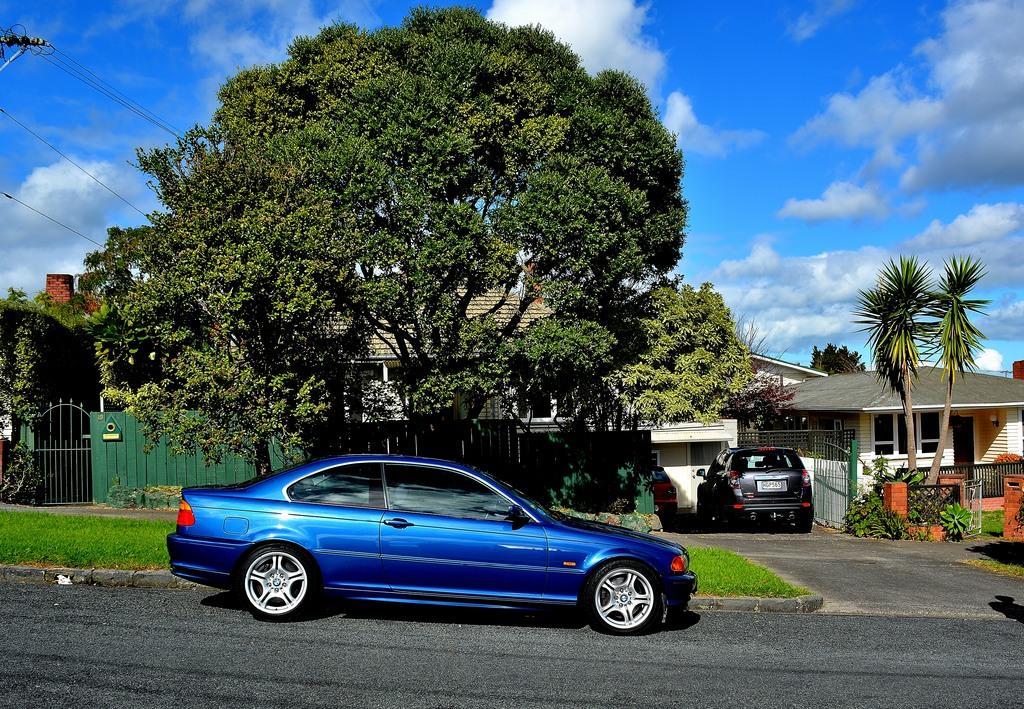What type of vehicles can be seen on the road in the image? There are cars on the road in the image. What type of vegetation is present in the image? There are trees in the image. What type of structures can be seen in the image? There are buildings with windows in the image. What type of ground cover is visible in the image? There is grass visible in the image. What can be seen in the background of the image? The sky with clouds is visible in the background of the image. What type of magic is being performed by the trees in the image? There is no magic being performed by the trees in the image; they are simply trees. What type of spark can be seen coming from the buildings in the image? There is no spark visible coming from the buildings in the image; they are just buildings with windows. 